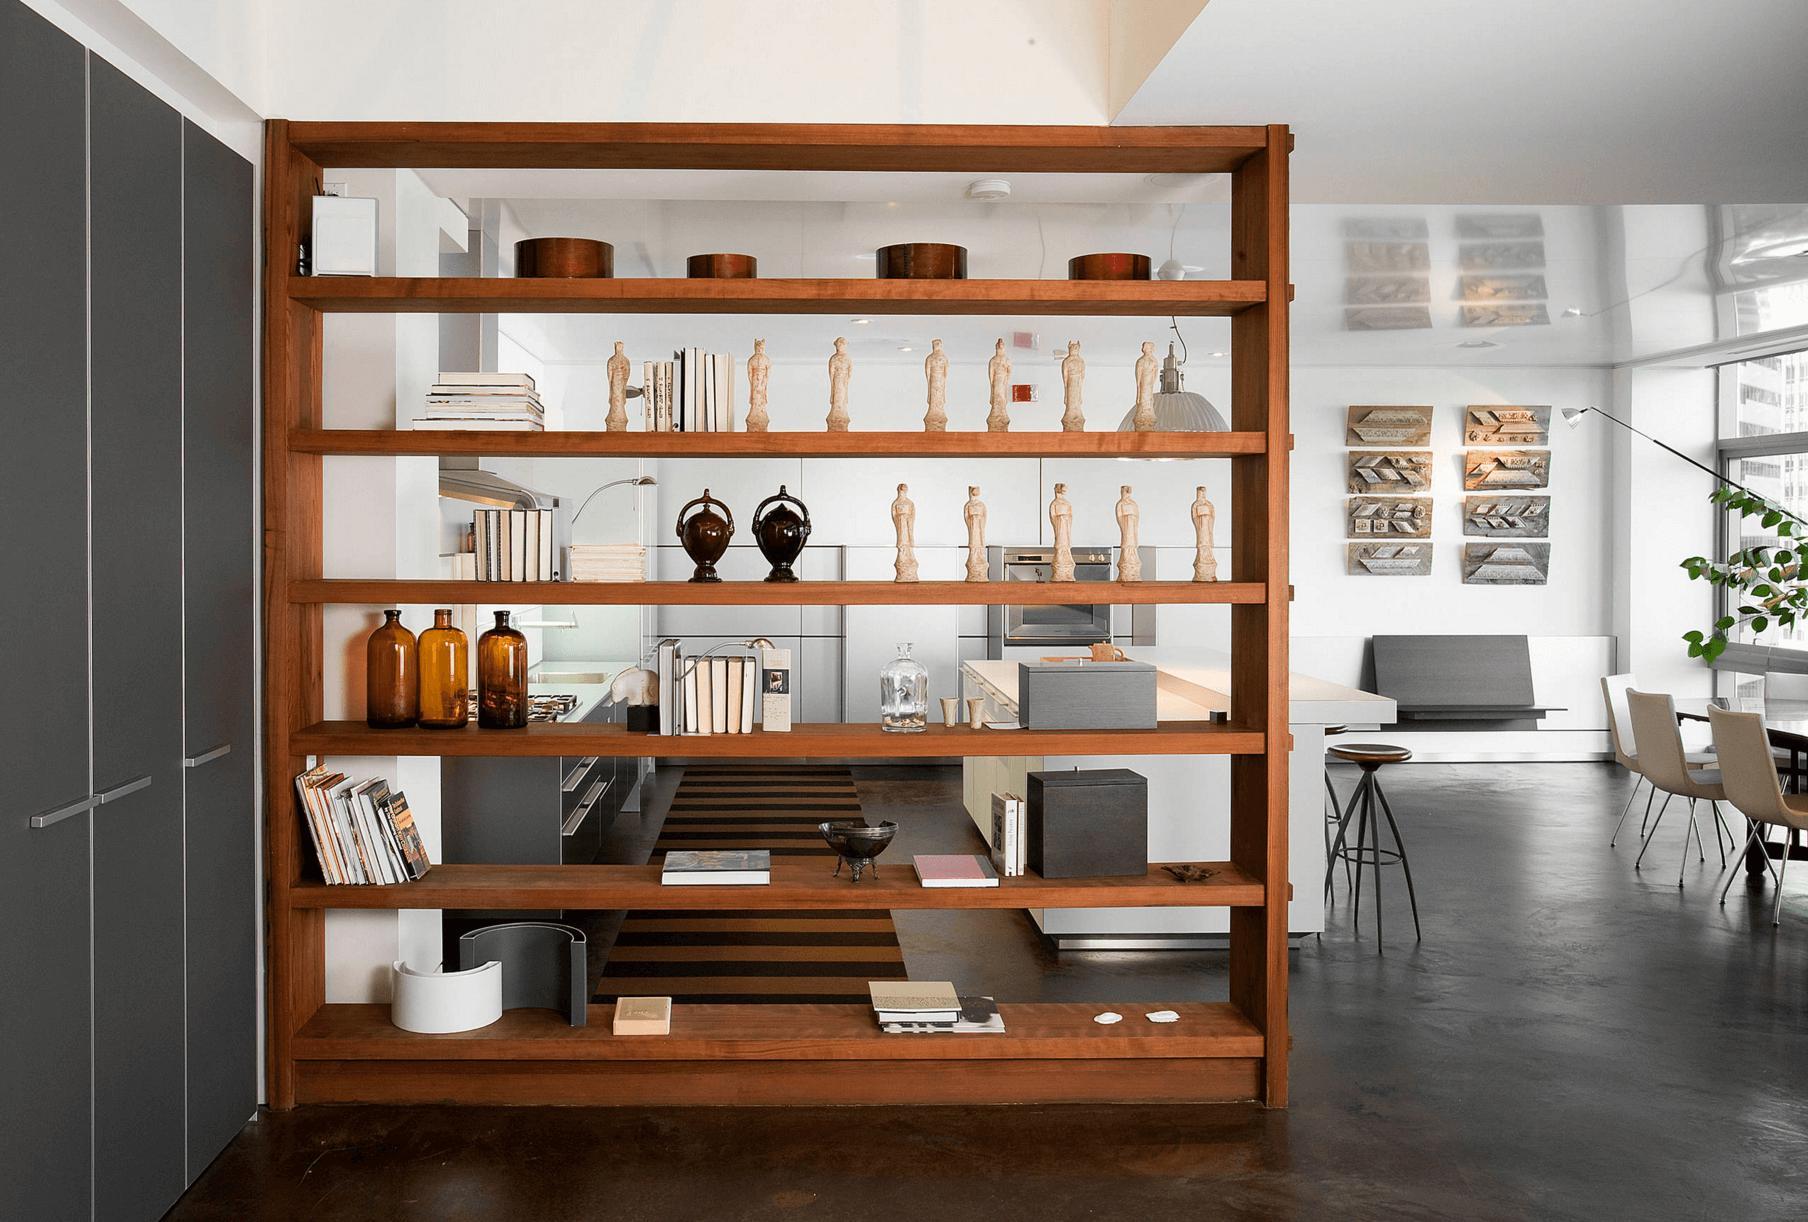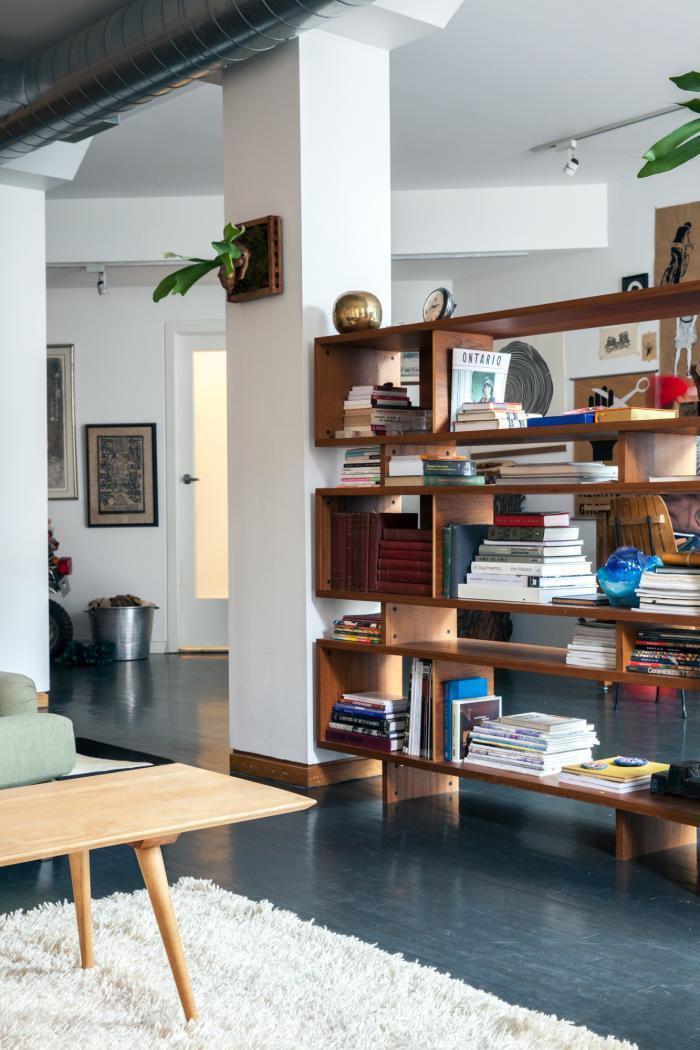The first image is the image on the left, the second image is the image on the right. For the images displayed, is the sentence "A white bookcase separates a bed from the rest of the living space." factually correct? Answer yes or no. No. The first image is the image on the left, the second image is the image on the right. Examine the images to the left and right. Is the description "In one image a large room-dividing shelf unit is placed near the foot of a bed." accurate? Answer yes or no. No. 